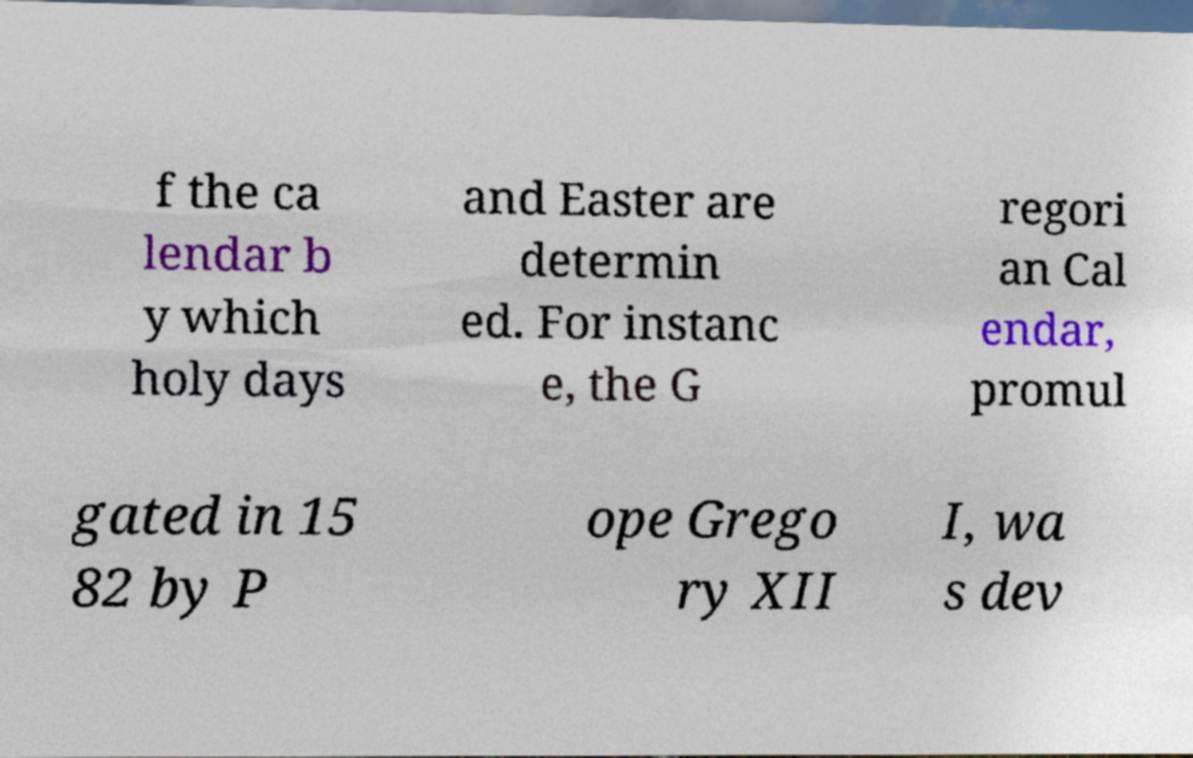There's text embedded in this image that I need extracted. Can you transcribe it verbatim? f the ca lendar b y which holy days and Easter are determin ed. For instanc e, the G regori an Cal endar, promul gated in 15 82 by P ope Grego ry XII I, wa s dev 